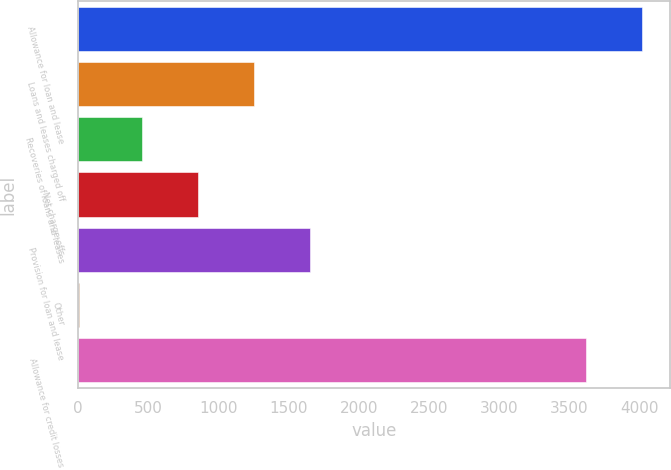Convert chart. <chart><loc_0><loc_0><loc_500><loc_500><bar_chart><fcel>Allowance for loan and lease<fcel>Loans and leases charged off<fcel>Recoveries of loans and leases<fcel>Net charge-offs<fcel>Provision for loan and lease<fcel>Other<fcel>Allowance for credit losses<nl><fcel>4019.1<fcel>1252.2<fcel>452<fcel>852.1<fcel>1652.3<fcel>4<fcel>3619<nl></chart> 